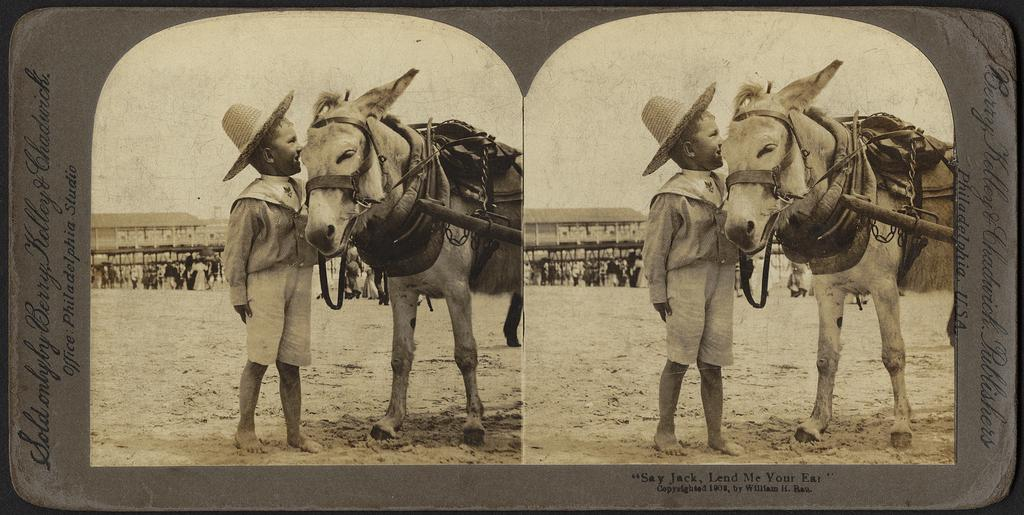What is the color scheme of the image? The image is black and white. What type of pictures are included in the image? There are collage pictures in the image. What subjects are featured in the collage pictures? The collage pictures include a person and a horse. Where are the collage pictures located? The collage pictures are on the sand. Is there a gate visible in the image? No, there is no gate present in the image. 